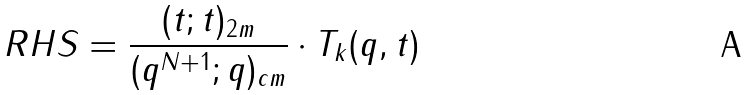<formula> <loc_0><loc_0><loc_500><loc_500>R H S = \frac { ( t ; t ) _ { 2 m } } { ( q ^ { N + 1 } ; q ) _ { c m } } \cdot T _ { k } ( q , t )</formula> 